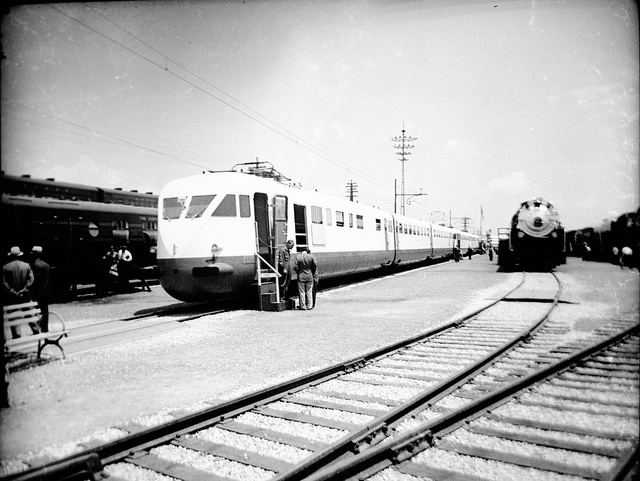Describe the objects in this image and their specific colors. I can see train in black, white, darkgray, and gray tones, train in black, gray, darkgray, and lightgray tones, train in black, lightgray, darkgray, and gray tones, train in black, gray, darkgray, and lightgray tones, and bench in black, darkgray, gray, and lightgray tones in this image. 